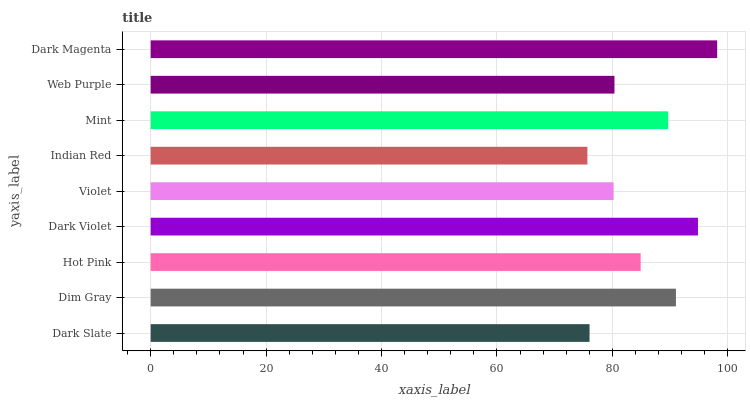Is Indian Red the minimum?
Answer yes or no. Yes. Is Dark Magenta the maximum?
Answer yes or no. Yes. Is Dim Gray the minimum?
Answer yes or no. No. Is Dim Gray the maximum?
Answer yes or no. No. Is Dim Gray greater than Dark Slate?
Answer yes or no. Yes. Is Dark Slate less than Dim Gray?
Answer yes or no. Yes. Is Dark Slate greater than Dim Gray?
Answer yes or no. No. Is Dim Gray less than Dark Slate?
Answer yes or no. No. Is Hot Pink the high median?
Answer yes or no. Yes. Is Hot Pink the low median?
Answer yes or no. Yes. Is Indian Red the high median?
Answer yes or no. No. Is Web Purple the low median?
Answer yes or no. No. 